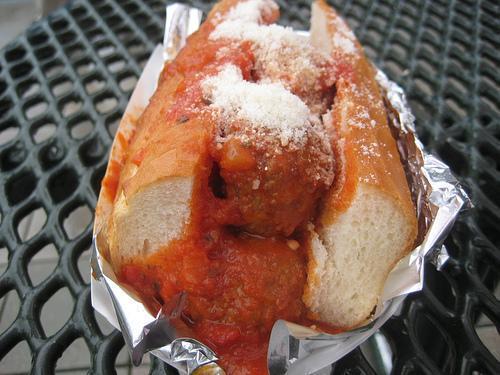How many sandwiches are there?
Give a very brief answer. 1. How many arched windows are there to the left of the clock tower?
Give a very brief answer. 0. 